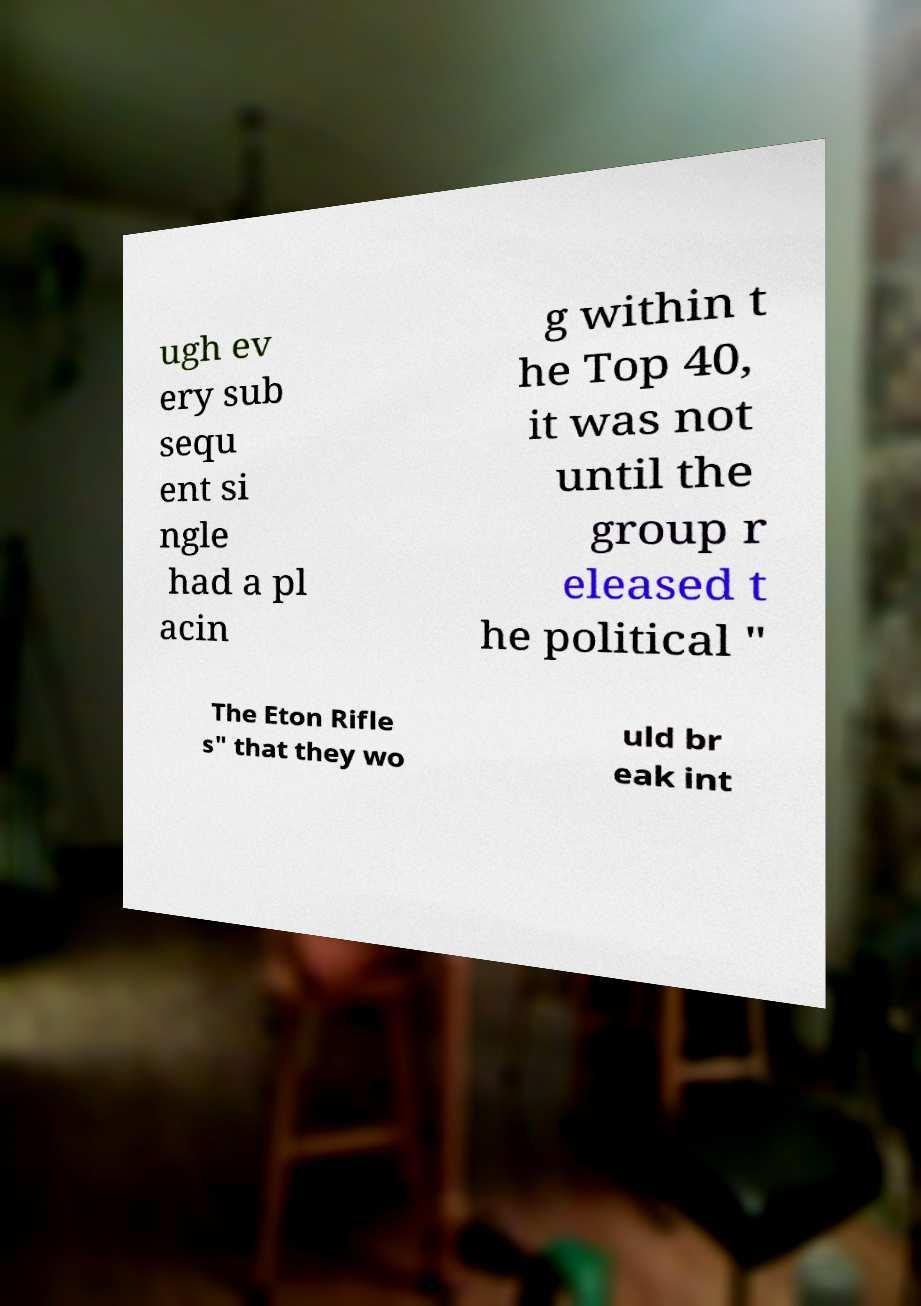Please read and relay the text visible in this image. What does it say? ugh ev ery sub sequ ent si ngle had a pl acin g within t he Top 40, it was not until the group r eleased t he political " The Eton Rifle s" that they wo uld br eak int 